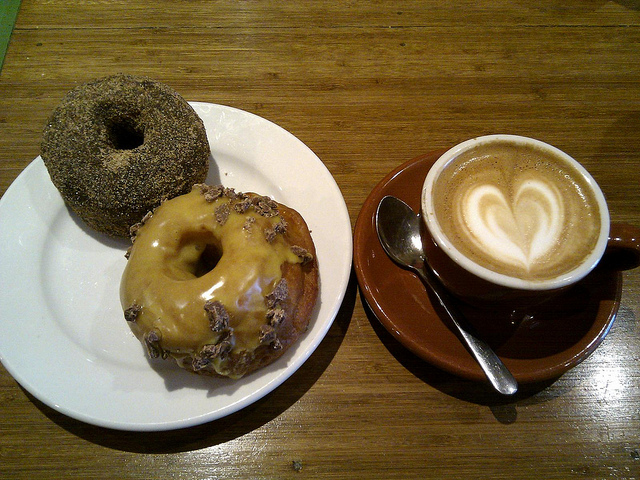Can you describe the doughnuts in detail? Certainly! The first doughnut is generously coated in fine sugar, providing a sweet, textured exterior while the second doughnut is adorned with a lustrous, caramel-colored glaze sprinkled with crunchy toppings, possibly nuts or cookie bits, enhancing its delectable appeal. 